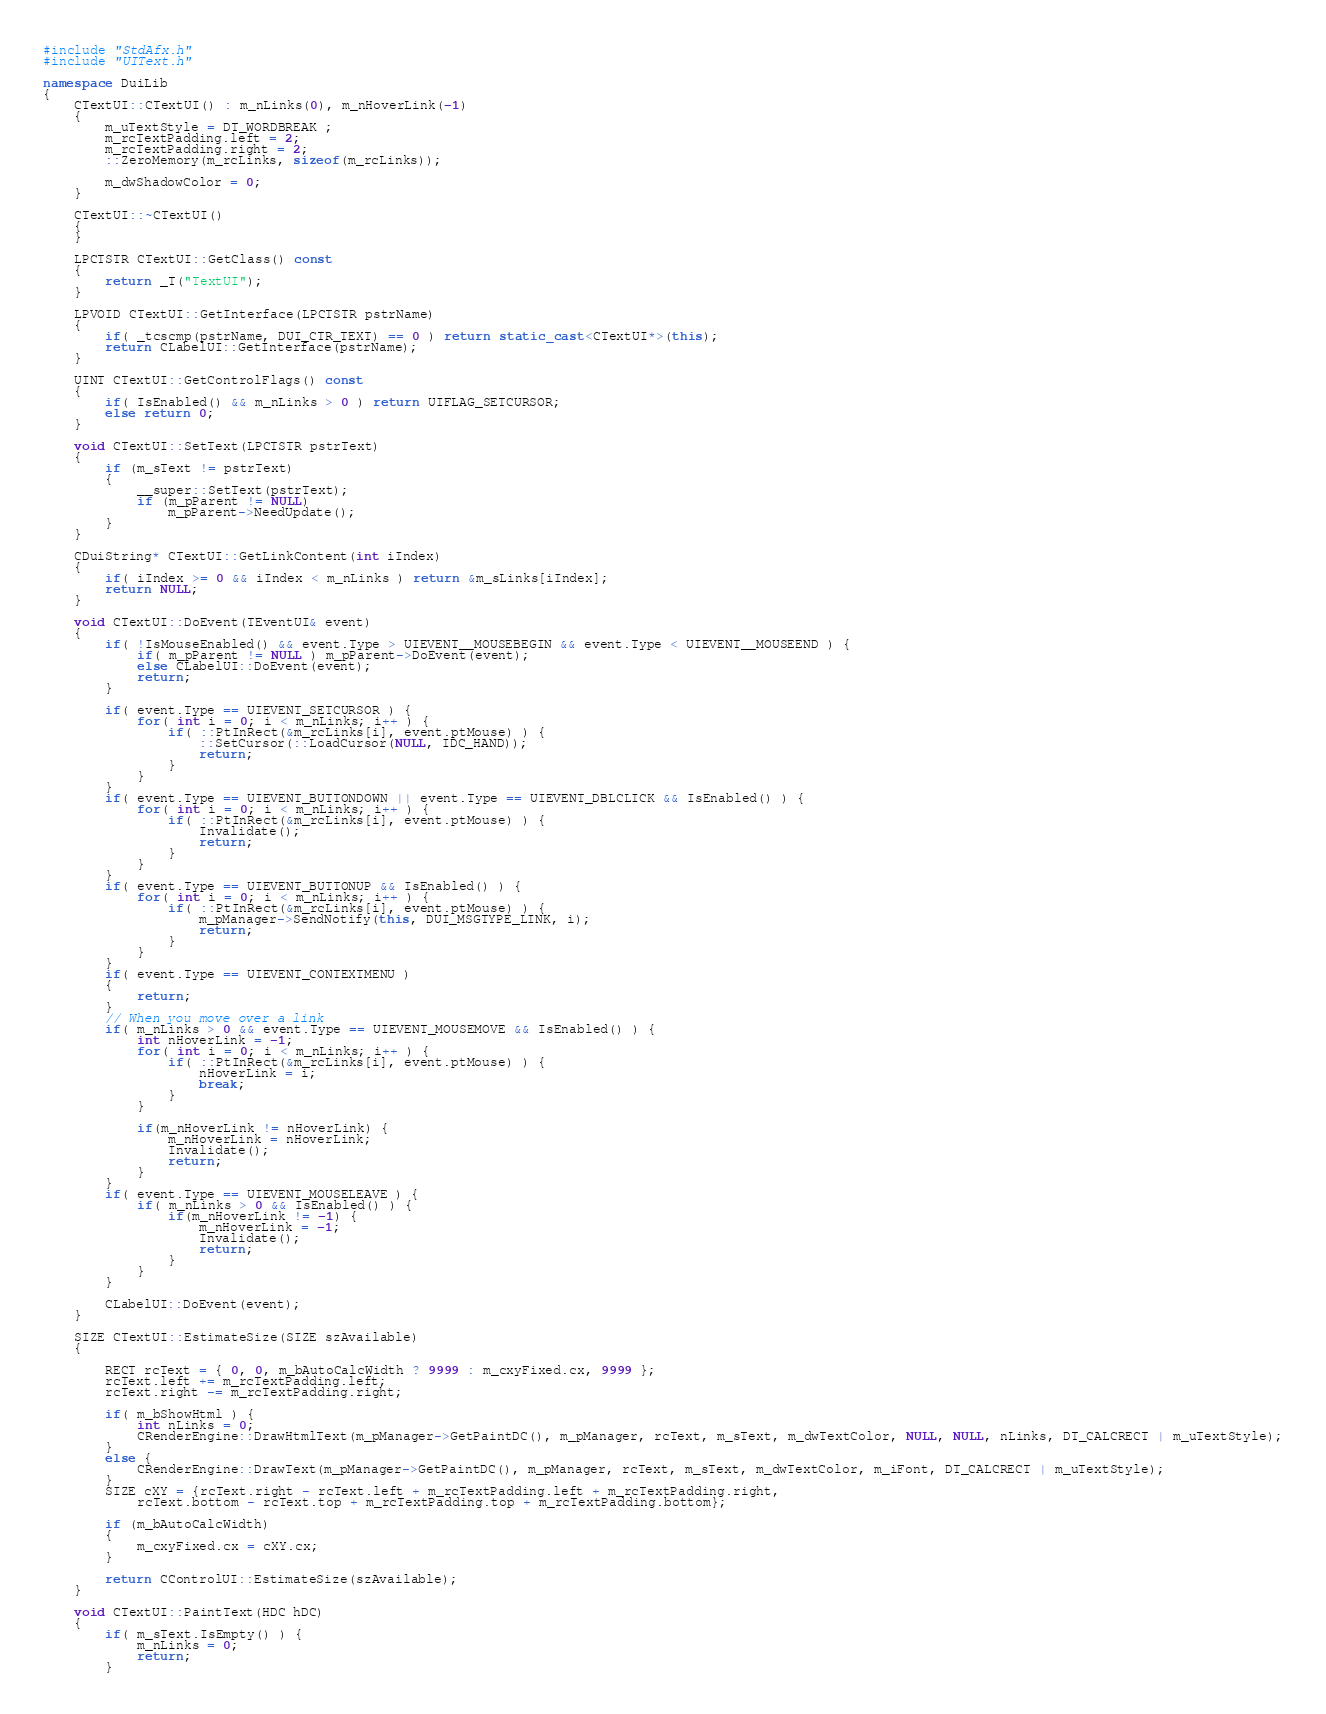Convert code to text. <code><loc_0><loc_0><loc_500><loc_500><_C++_>#include "StdAfx.h"
#include "UIText.h"

namespace DuiLib
{
	CTextUI::CTextUI() : m_nLinks(0), m_nHoverLink(-1)
	{
		m_uTextStyle = DT_WORDBREAK ;
		m_rcTextPadding.left = 2;
		m_rcTextPadding.right = 2;
		::ZeroMemory(m_rcLinks, sizeof(m_rcLinks));

		m_dwShadowColor = 0;
	}

	CTextUI::~CTextUI()
	{
	}

	LPCTSTR CTextUI::GetClass() const
	{
		return _T("TextUI");
	}

	LPVOID CTextUI::GetInterface(LPCTSTR pstrName)
	{
		if( _tcscmp(pstrName, DUI_CTR_TEXT) == 0 ) return static_cast<CTextUI*>(this);
		return CLabelUI::GetInterface(pstrName);
	}

	UINT CTextUI::GetControlFlags() const
	{
		if( IsEnabled() && m_nLinks > 0 ) return UIFLAG_SETCURSOR;
		else return 0;
	}

	void CTextUI::SetText(LPCTSTR pstrText)
	{
		if (m_sText != pstrText)
		{
			__super::SetText(pstrText);
			if (m_pParent != NULL)
				m_pParent->NeedUpdate();
		}	
	}

	CDuiString* CTextUI::GetLinkContent(int iIndex)
	{
		if( iIndex >= 0 && iIndex < m_nLinks ) return &m_sLinks[iIndex];
		return NULL;
	}

	void CTextUI::DoEvent(TEventUI& event)
	{
		if( !IsMouseEnabled() && event.Type > UIEVENT__MOUSEBEGIN && event.Type < UIEVENT__MOUSEEND ) {
			if( m_pParent != NULL ) m_pParent->DoEvent(event);
			else CLabelUI::DoEvent(event);
			return;
		}

		if( event.Type == UIEVENT_SETCURSOR ) {
			for( int i = 0; i < m_nLinks; i++ ) {
				if( ::PtInRect(&m_rcLinks[i], event.ptMouse) ) {
					::SetCursor(::LoadCursor(NULL, IDC_HAND));
					return;
				}
			}
		}
		if( event.Type == UIEVENT_BUTTONDOWN || event.Type == UIEVENT_DBLCLICK && IsEnabled() ) {
			for( int i = 0; i < m_nLinks; i++ ) {
				if( ::PtInRect(&m_rcLinks[i], event.ptMouse) ) {
					Invalidate();
					return;
				}
			}
		}
		if( event.Type == UIEVENT_BUTTONUP && IsEnabled() ) {
			for( int i = 0; i < m_nLinks; i++ ) {
				if( ::PtInRect(&m_rcLinks[i], event.ptMouse) ) {
					m_pManager->SendNotify(this, DUI_MSGTYPE_LINK, i);
					return;
				}
			}
		}
		if( event.Type == UIEVENT_CONTEXTMENU )
		{
			return;
		}
		// When you move over a link
		if( m_nLinks > 0 && event.Type == UIEVENT_MOUSEMOVE && IsEnabled() ) {
			int nHoverLink = -1;
			for( int i = 0; i < m_nLinks; i++ ) {
				if( ::PtInRect(&m_rcLinks[i], event.ptMouse) ) {
					nHoverLink = i;
					break;
				}
			}

			if(m_nHoverLink != nHoverLink) {
				m_nHoverLink = nHoverLink;
				Invalidate();
				return;
			}      
		}
		if( event.Type == UIEVENT_MOUSELEAVE ) {
			if( m_nLinks > 0 && IsEnabled() ) {
				if(m_nHoverLink != -1) {
					m_nHoverLink = -1;
					Invalidate();
					return;
				}
			}
		}

		CLabelUI::DoEvent(event);
	}

	SIZE CTextUI::EstimateSize(SIZE szAvailable)
	{

		RECT rcText = { 0, 0, m_bAutoCalcWidth ? 9999 : m_cxyFixed.cx, 9999 };
		rcText.left += m_rcTextPadding.left;
		rcText.right -= m_rcTextPadding.right;

		if( m_bShowHtml ) {   
			int nLinks = 0;
			CRenderEngine::DrawHtmlText(m_pManager->GetPaintDC(), m_pManager, rcText, m_sText, m_dwTextColor, NULL, NULL, nLinks, DT_CALCRECT | m_uTextStyle);
		}
		else {
			CRenderEngine::DrawText(m_pManager->GetPaintDC(), m_pManager, rcText, m_sText, m_dwTextColor, m_iFont, DT_CALCRECT | m_uTextStyle);
		}
		SIZE cXY = {rcText.right - rcText.left + m_rcTextPadding.left + m_rcTextPadding.right,
			rcText.bottom - rcText.top + m_rcTextPadding.top + m_rcTextPadding.bottom};
		
		if (m_bAutoCalcWidth)
		{
			m_cxyFixed.cx = cXY.cx;
		}

		return CControlUI::EstimateSize(szAvailable);
	}

	void CTextUI::PaintText(HDC hDC)
	{
		if( m_sText.IsEmpty() ) {
			m_nLinks = 0;
			return;
		}
</code> 